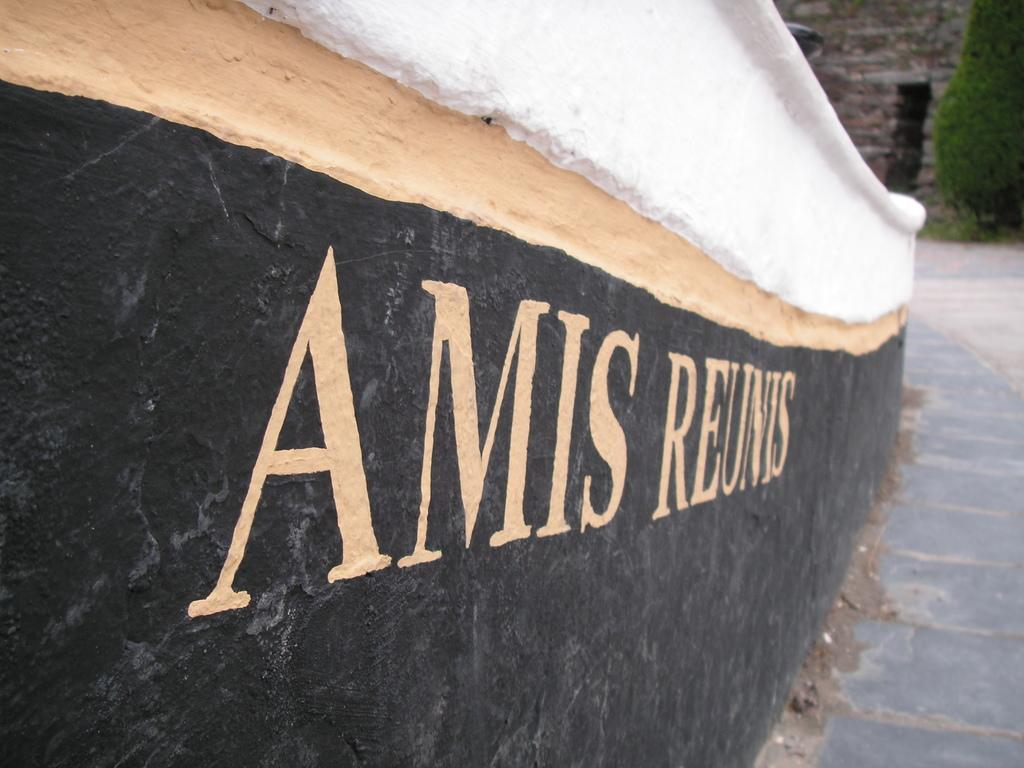What type of structure can be seen in the image? There are walls in the image, which suggests a structure. What is the surface beneath the walls? There is a floor in the image. What is written on the wall? There is writing on the wall. What can be seen in the background of the image? There is a tree in the background of the image. What type of cushion is used to support the history in the image? There is no cushion or history present in the image; it only features walls, a floor, writing on the wall, and a tree in the background. 